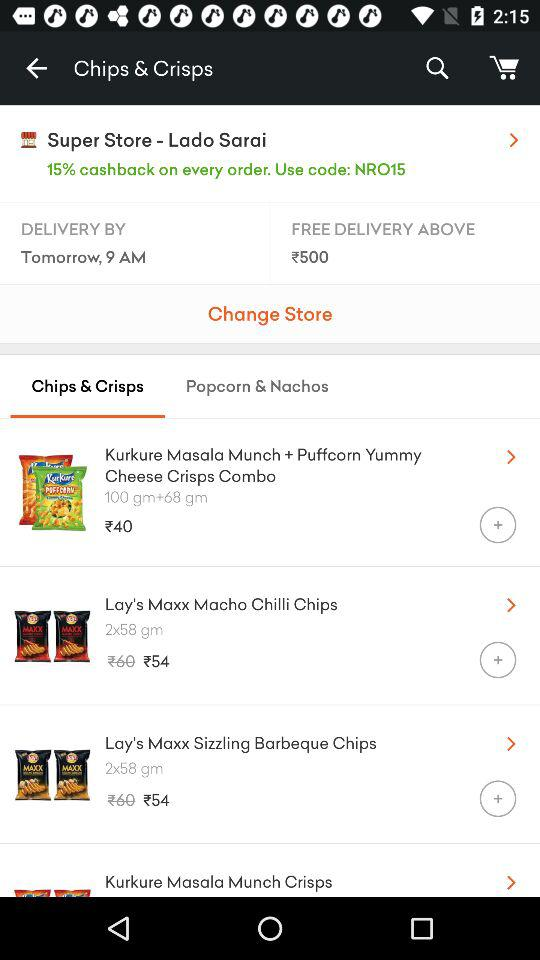What's the price of Kurkure?
When the provided information is insufficient, respond with <no answer>. <no answer> 